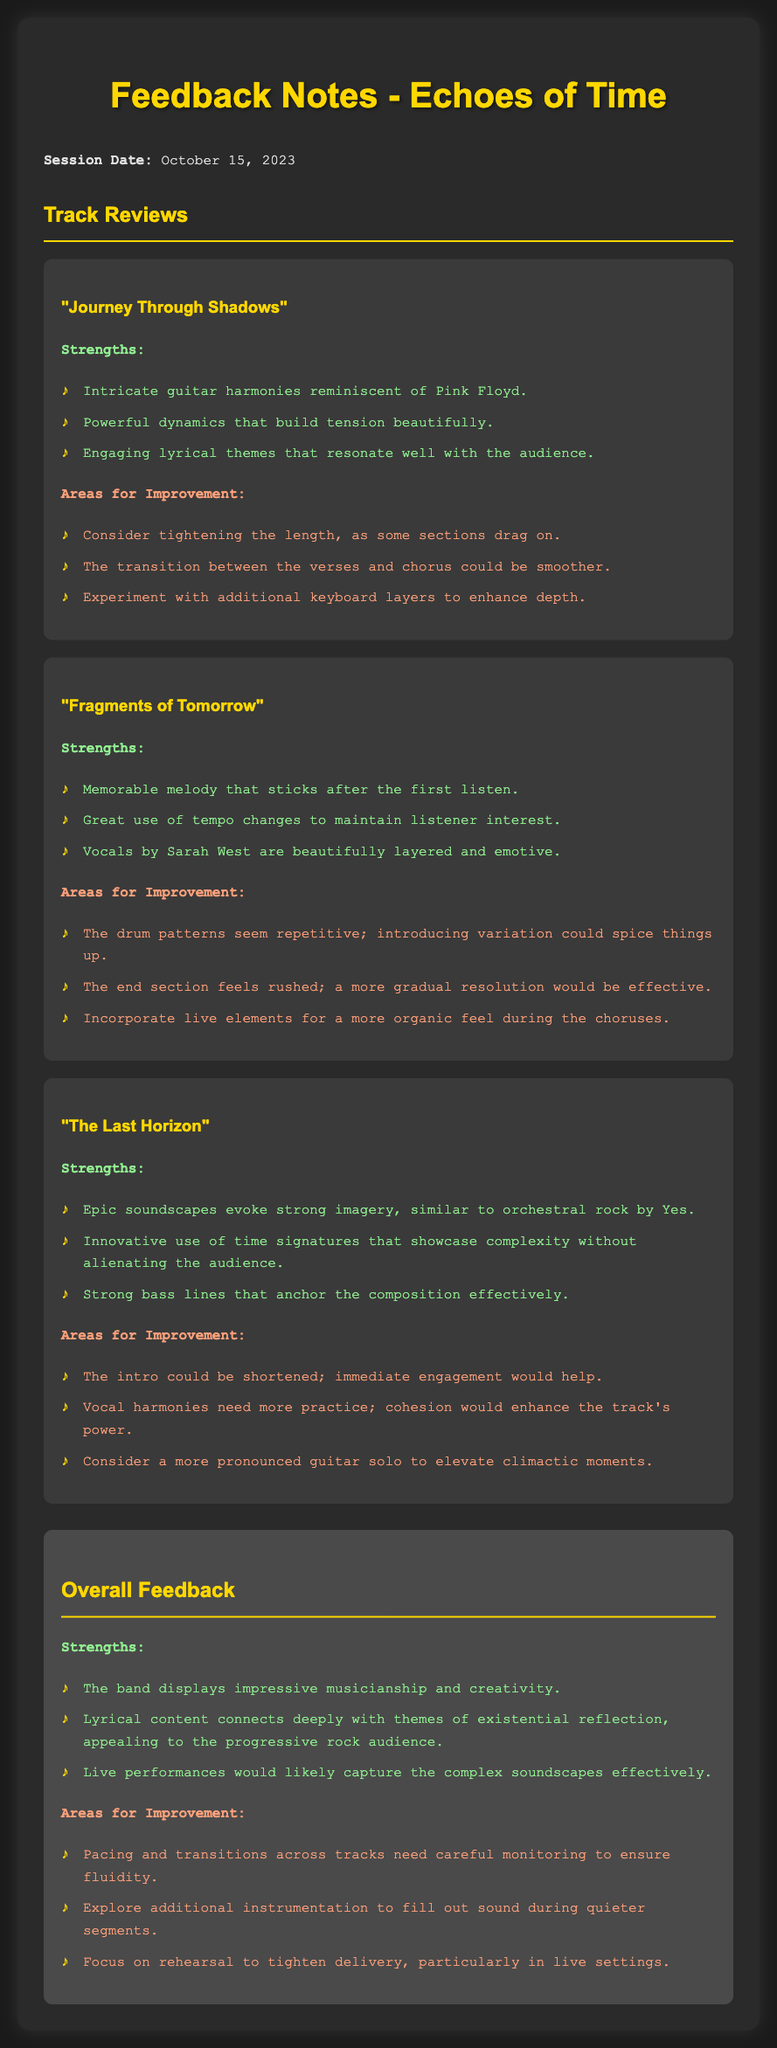What is the title of the first track reviewed? The document provides the titles of each track being reviewed and lists "Journey Through Shadows" as the first.
Answer: Journey Through Shadows Who is the vocalist for "Fragments of Tomorrow"? The feedback notes indicate that the vocalist for this track is Sarah West.
Answer: Sarah West What is a notable strength of "The Last Horizon"? The document highlights that "The Last Horizon" features epic soundscapes, drawing a comparison to orchestral rock by Yes.
Answer: Epic soundscapes What area for improvement is suggested for the track "Journey Through Shadows"? The document mentions that tightening the length of some sections is an improvement suggestion.
Answer: Tightening the length Which aspect of the overall feedback concerns pacing? The overall feedback discusses the need for careful monitoring of pacing across tracks to ensure fluidity.
Answer: Pacing and transitions What is a suggested enhancement for "Fragments of Tomorrow"? The feedback notes suggest incorporating live elements for a more organic feel during the choruses.
Answer: Incorporate live elements How many strengths are listed for "The Last Horizon"? The strengths section of "The Last Horizon" details three specific strengths mentioned in the document.
Answer: Three What should the band focus on for rehearsal improvements? The overall feedback advises focusing on rehearsal to tighten delivery, particularly in live settings.
Answer: Tighten delivery What date was the listening session conducted? The document provides the date of the listening session as October 15, 2023.
Answer: October 15, 2023 